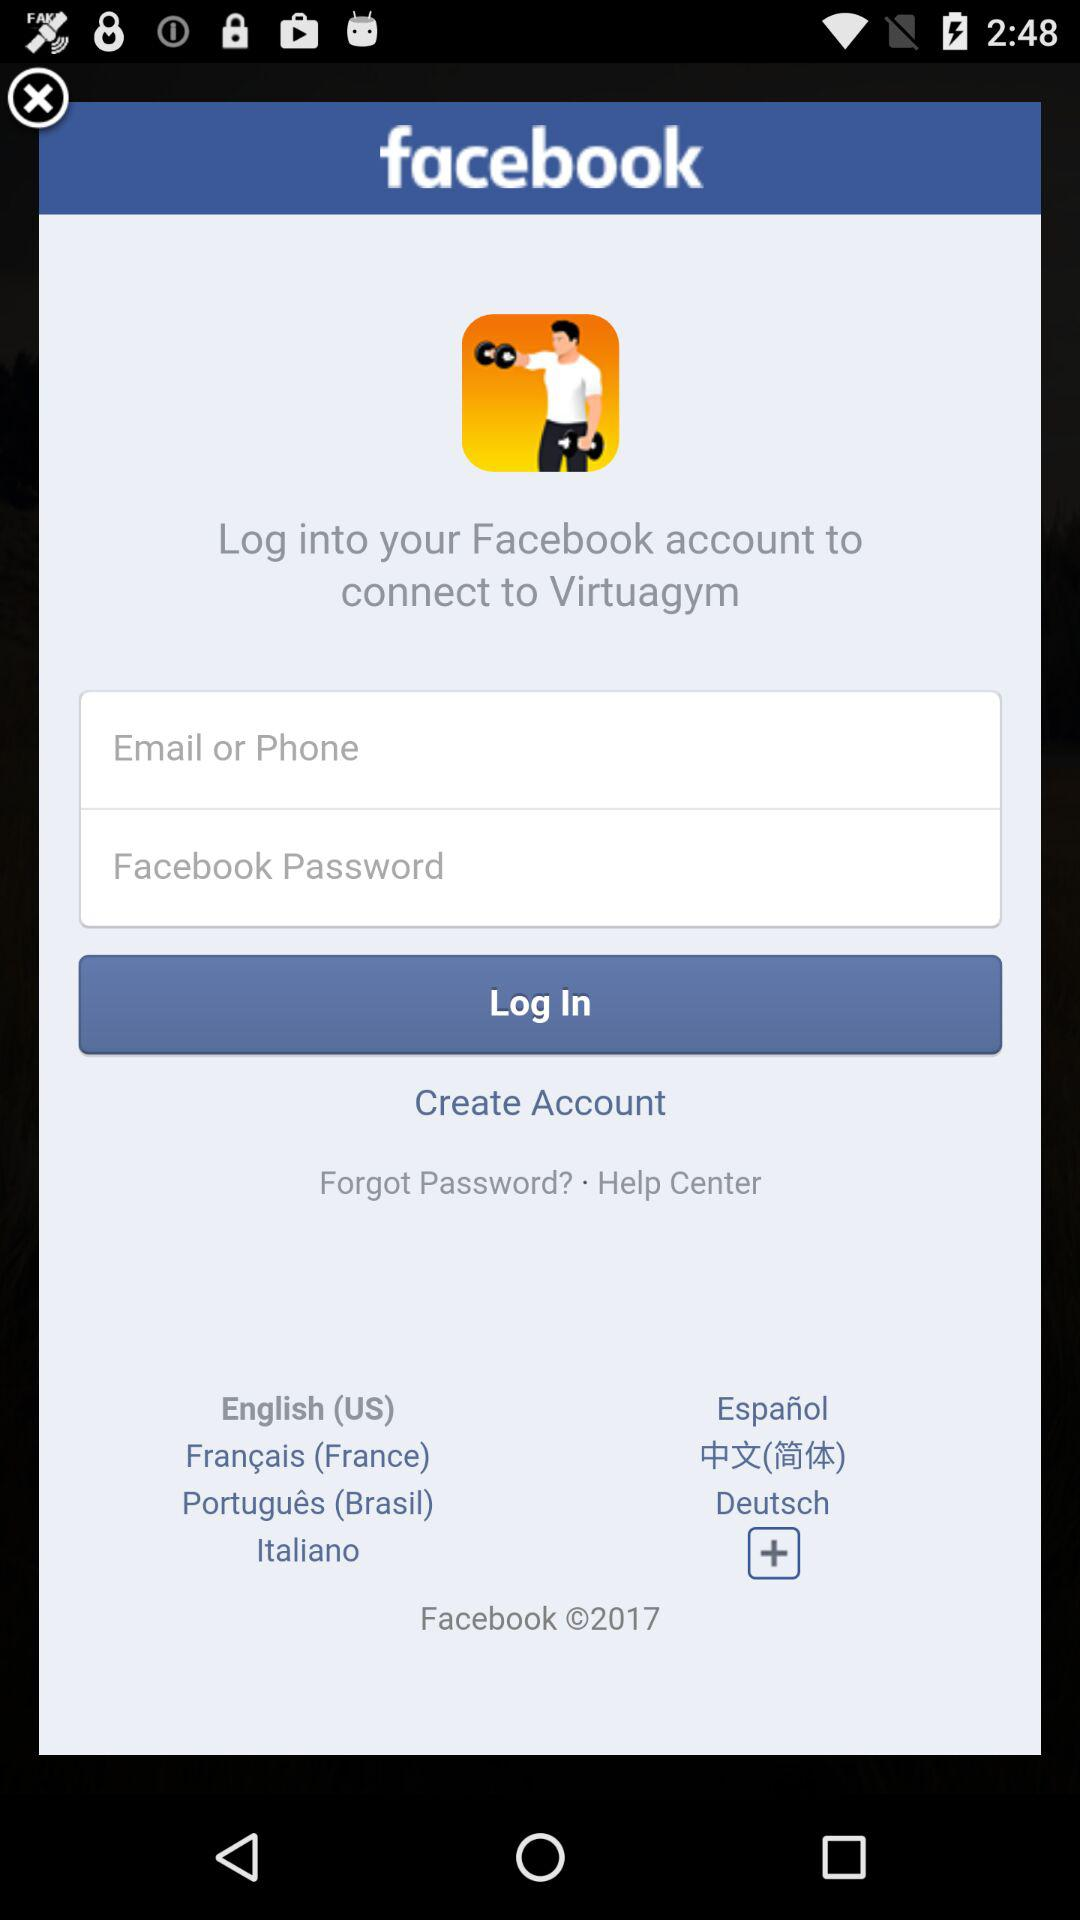How many languages are available for users to select from?
Answer the question using a single word or phrase. 7 